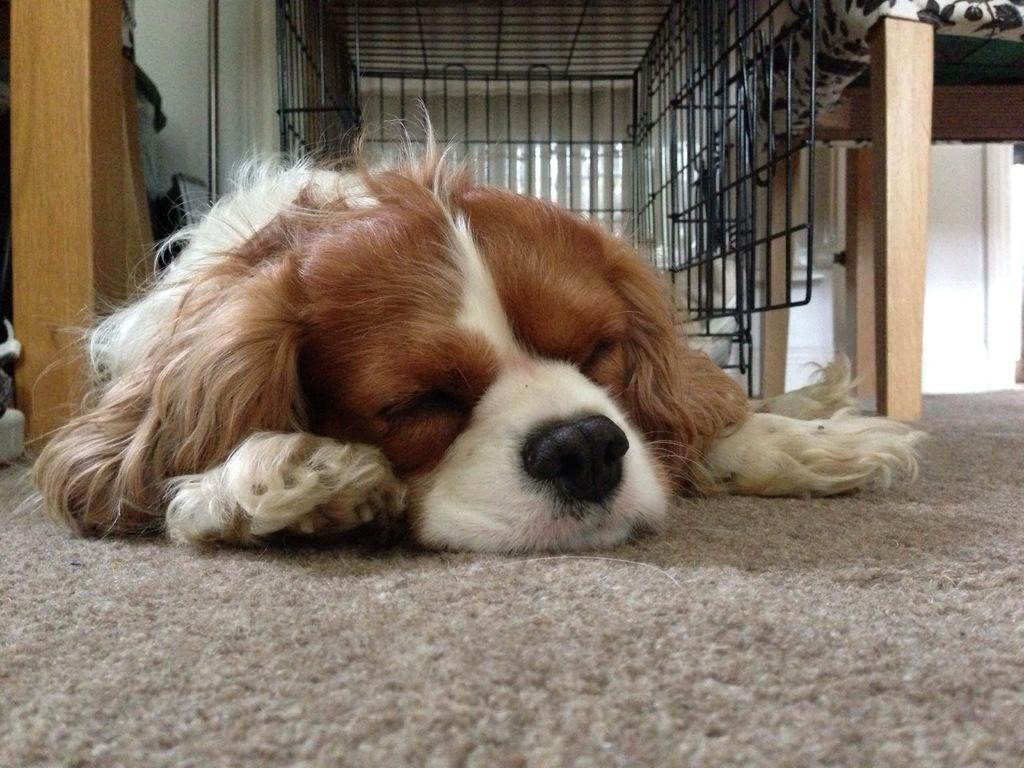What is the dog doing in the image? The dog is laying on a mat in the image. What type of furniture is present in the image? There is a cot in the image. What material is used for the objects in the image? Wooden objects are present in the image. What is the purpose of the rod in the image? The purpose of the rod is not clear from the image, but it might be used for hanging or supporting something. Can you describe the other objects in the image? There are other objects in the image, but their specific details are not mentioned in the facts. What is the background of the image? There is a wall in the image, and grilles are visible in the background. What type of tent is visible in the image? There is no tent present in the image. How does the dog attack the other objects in the image? The dog is not attacking any objects in the image; it is laying on a mat. What type of face can be seen on the dog in the image? The image does not show the dog's face, so it cannot be described. 